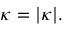<formula> <loc_0><loc_0><loc_500><loc_500>\kappa = | { \kappa } | .</formula> 